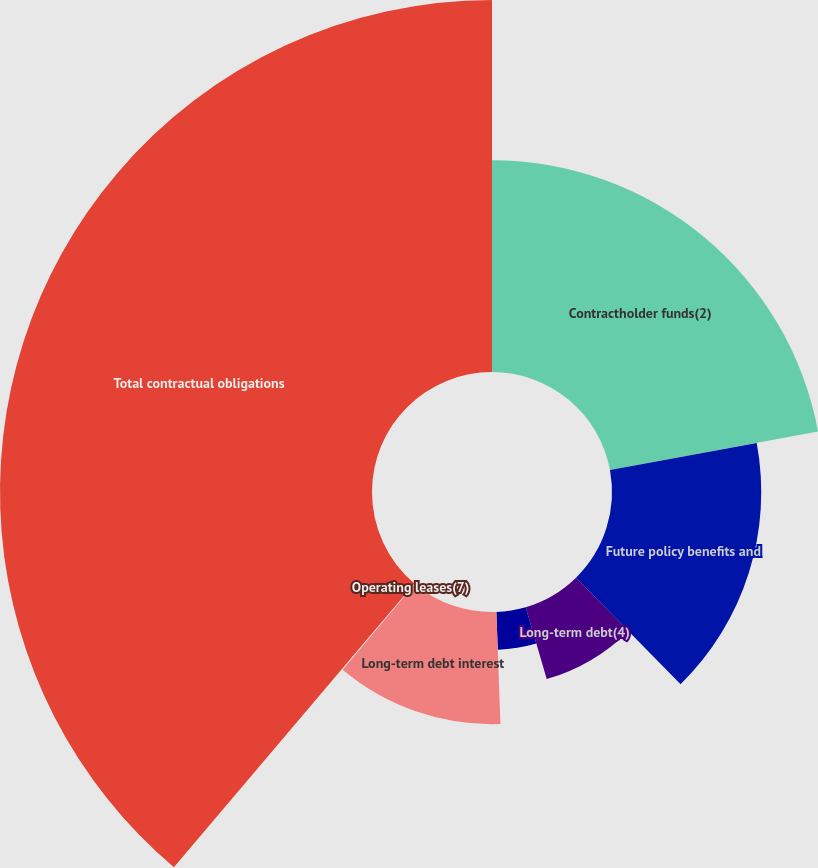Convert chart to OTSL. <chart><loc_0><loc_0><loc_500><loc_500><pie_chart><fcel>Contractholder funds(2)<fcel>Future policy benefits and<fcel>Long-term debt(4)<fcel>Certificates of deposit(5)<fcel>Long-term debt interest<fcel>Operating leases(7)<fcel>Total contractual obligations<nl><fcel>22.08%<fcel>15.57%<fcel>7.82%<fcel>3.95%<fcel>11.7%<fcel>0.07%<fcel>38.81%<nl></chart> 